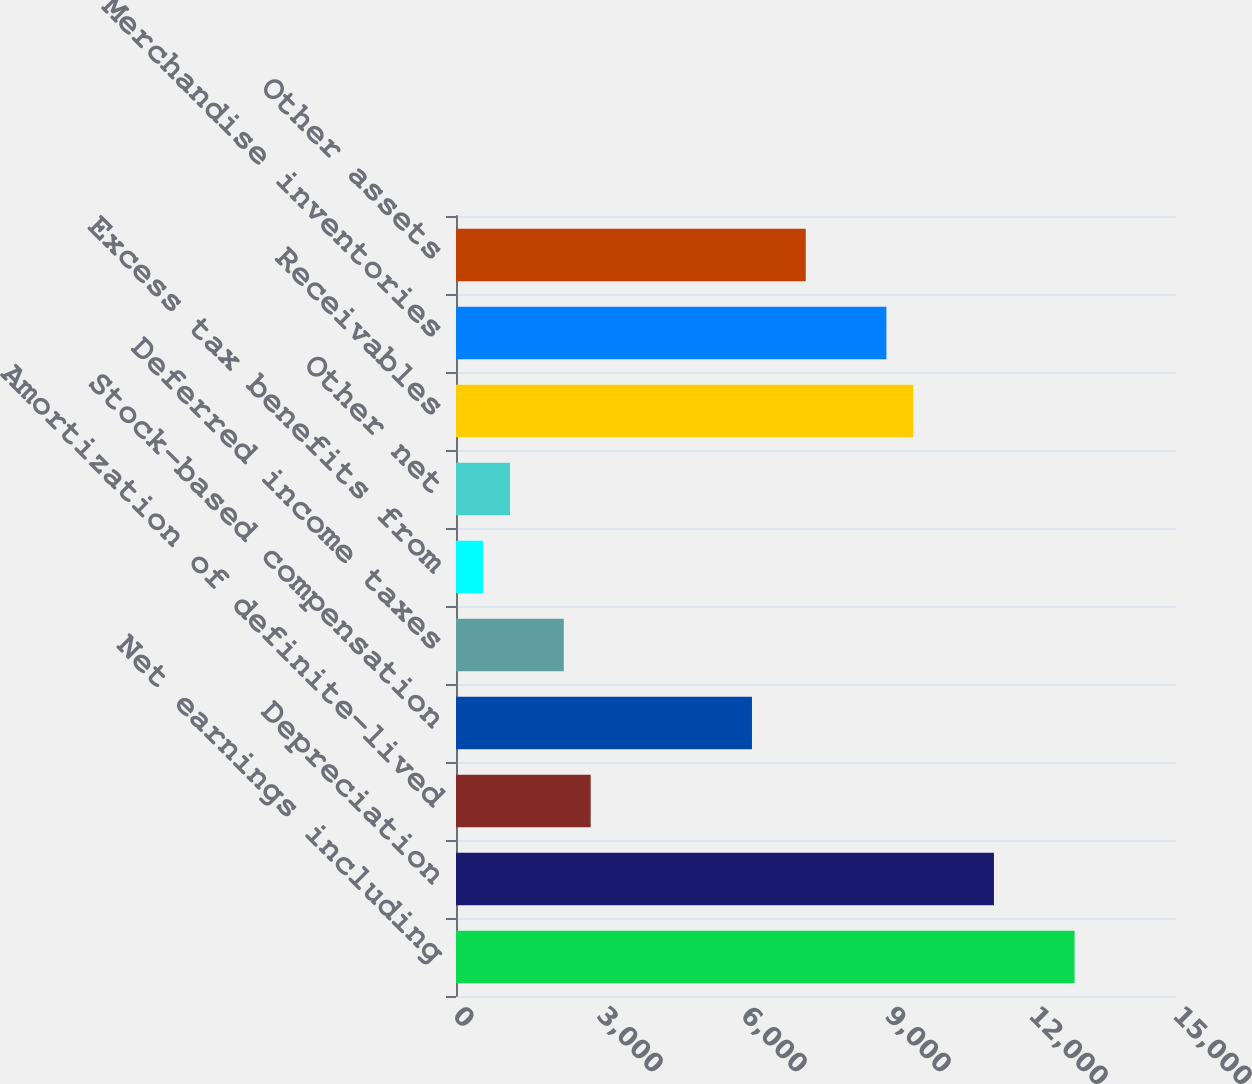<chart> <loc_0><loc_0><loc_500><loc_500><bar_chart><fcel>Net earnings including<fcel>Depreciation<fcel>Amortization of definite-lived<fcel>Stock-based compensation<fcel>Deferred income taxes<fcel>Excess tax benefits from<fcel>Other net<fcel>Receivables<fcel>Merchandise inventories<fcel>Other assets<nl><fcel>12887.3<fcel>11207<fcel>2805.5<fcel>6166.1<fcel>2245.4<fcel>565.1<fcel>1125.2<fcel>9526.7<fcel>8966.6<fcel>7286.3<nl></chart> 